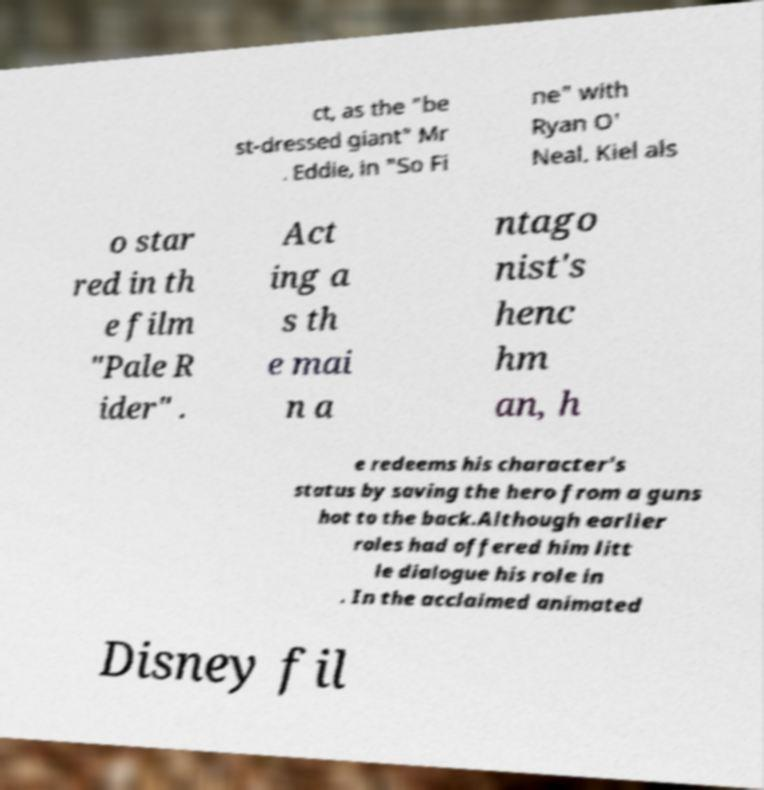What messages or text are displayed in this image? I need them in a readable, typed format. ct, as the "be st-dressed giant" Mr . Eddie, in "So Fi ne" with Ryan O' Neal. Kiel als o star red in th e film "Pale R ider" . Act ing a s th e mai n a ntago nist's henc hm an, h e redeems his character's status by saving the hero from a guns hot to the back.Although earlier roles had offered him litt le dialogue his role in . In the acclaimed animated Disney fil 